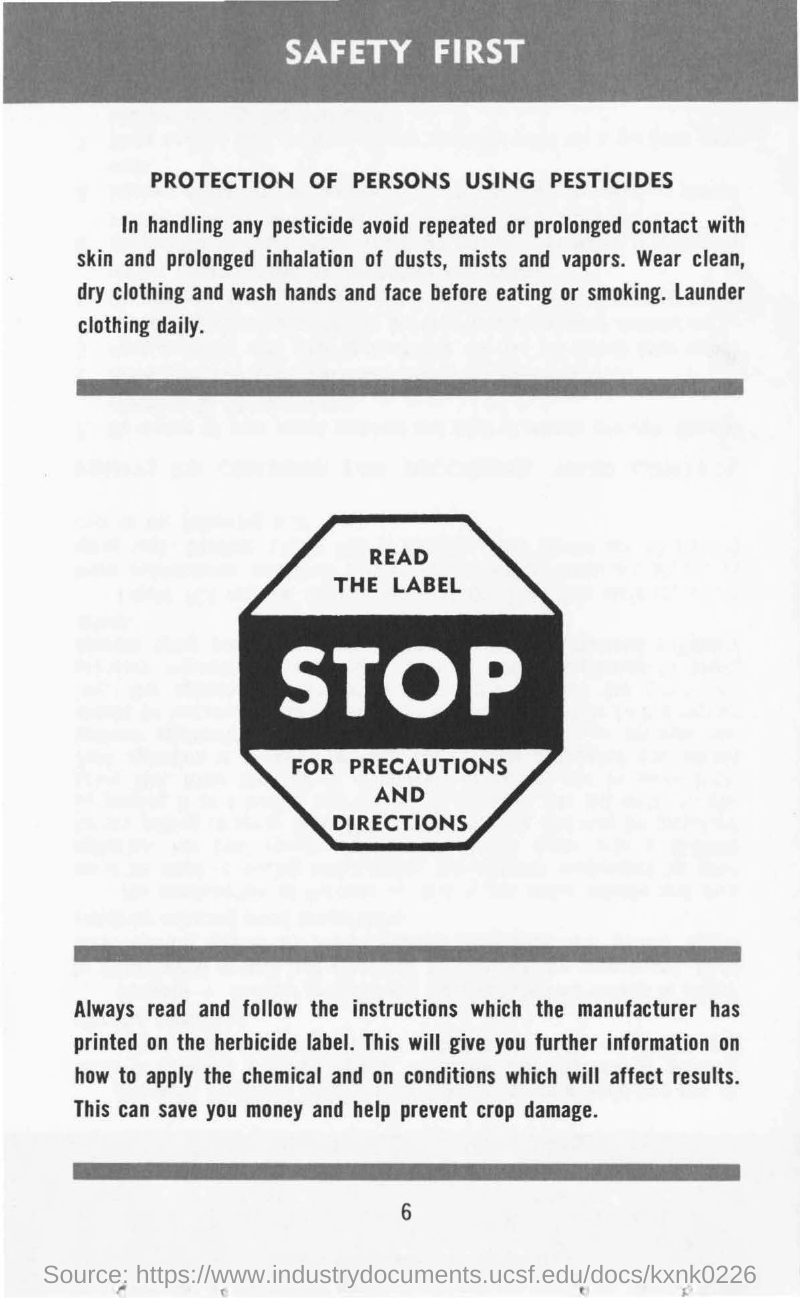Outline some significant characteristics in this image. It is necessary for us to read and follow the INSTRUCTIONS that have been provided. It is imperative to prioritize safety in all circumstances. The manufacturer is the entity responsible for printing the instructions. The location where the instructions for using herbicides are printed can be found on the herbicide label. 